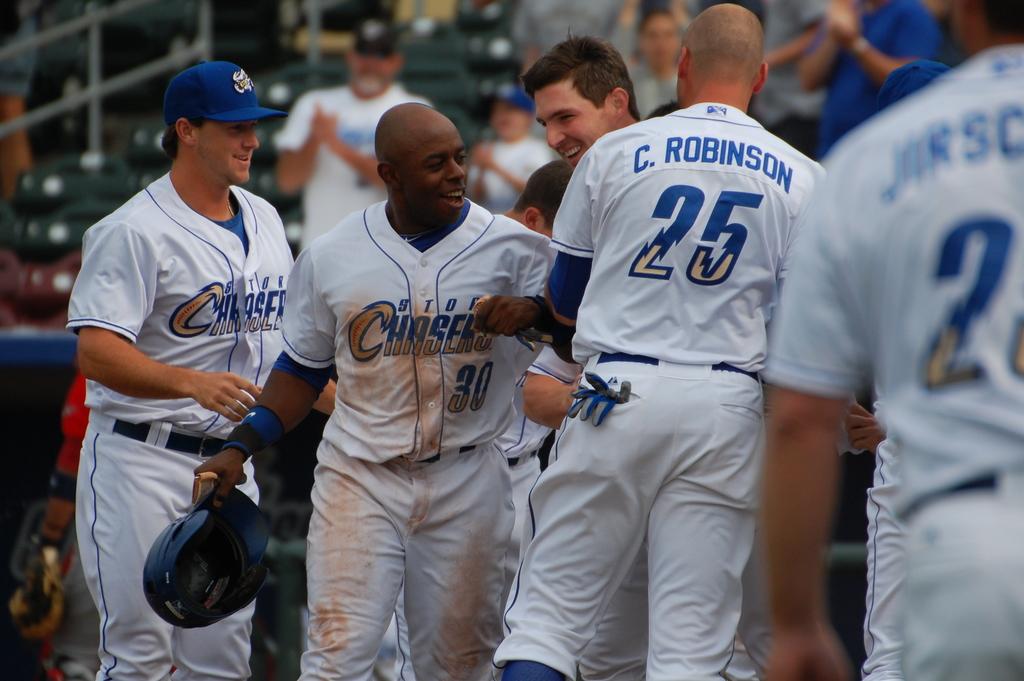Which team is featured?
Your answer should be compact. Storm chasers. 